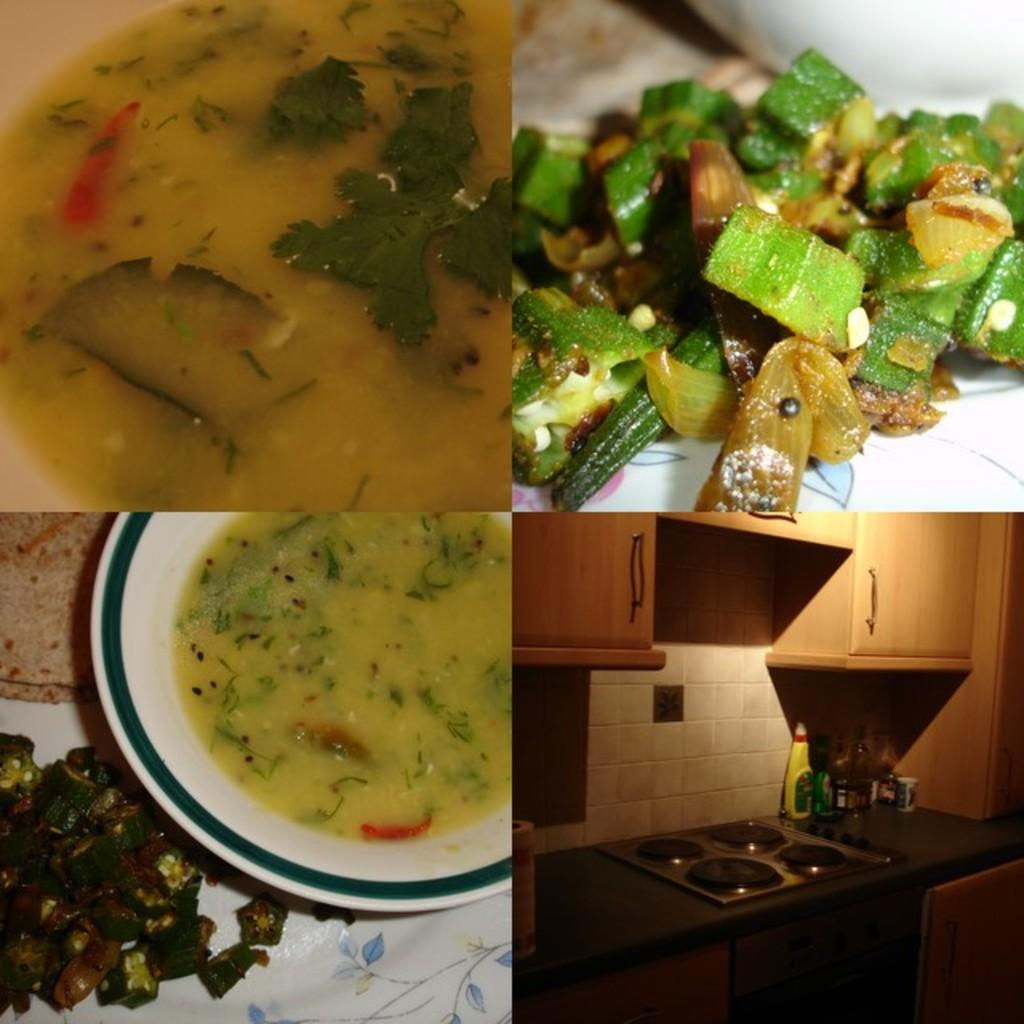How many images are present in the picture? There are four different images in the picture. What is the food placed in? The food is placed in bowls and plates. Where is the food located? The food is placed on a table. What type of hose can be seen spraying water on the food in the image? There is no hose present in the image, nor is there any water being sprayed on the food. How many grapes are visible in the image? There is no mention of grapes in the provided facts, so it cannot be determined how many grapes are visible in the image. 